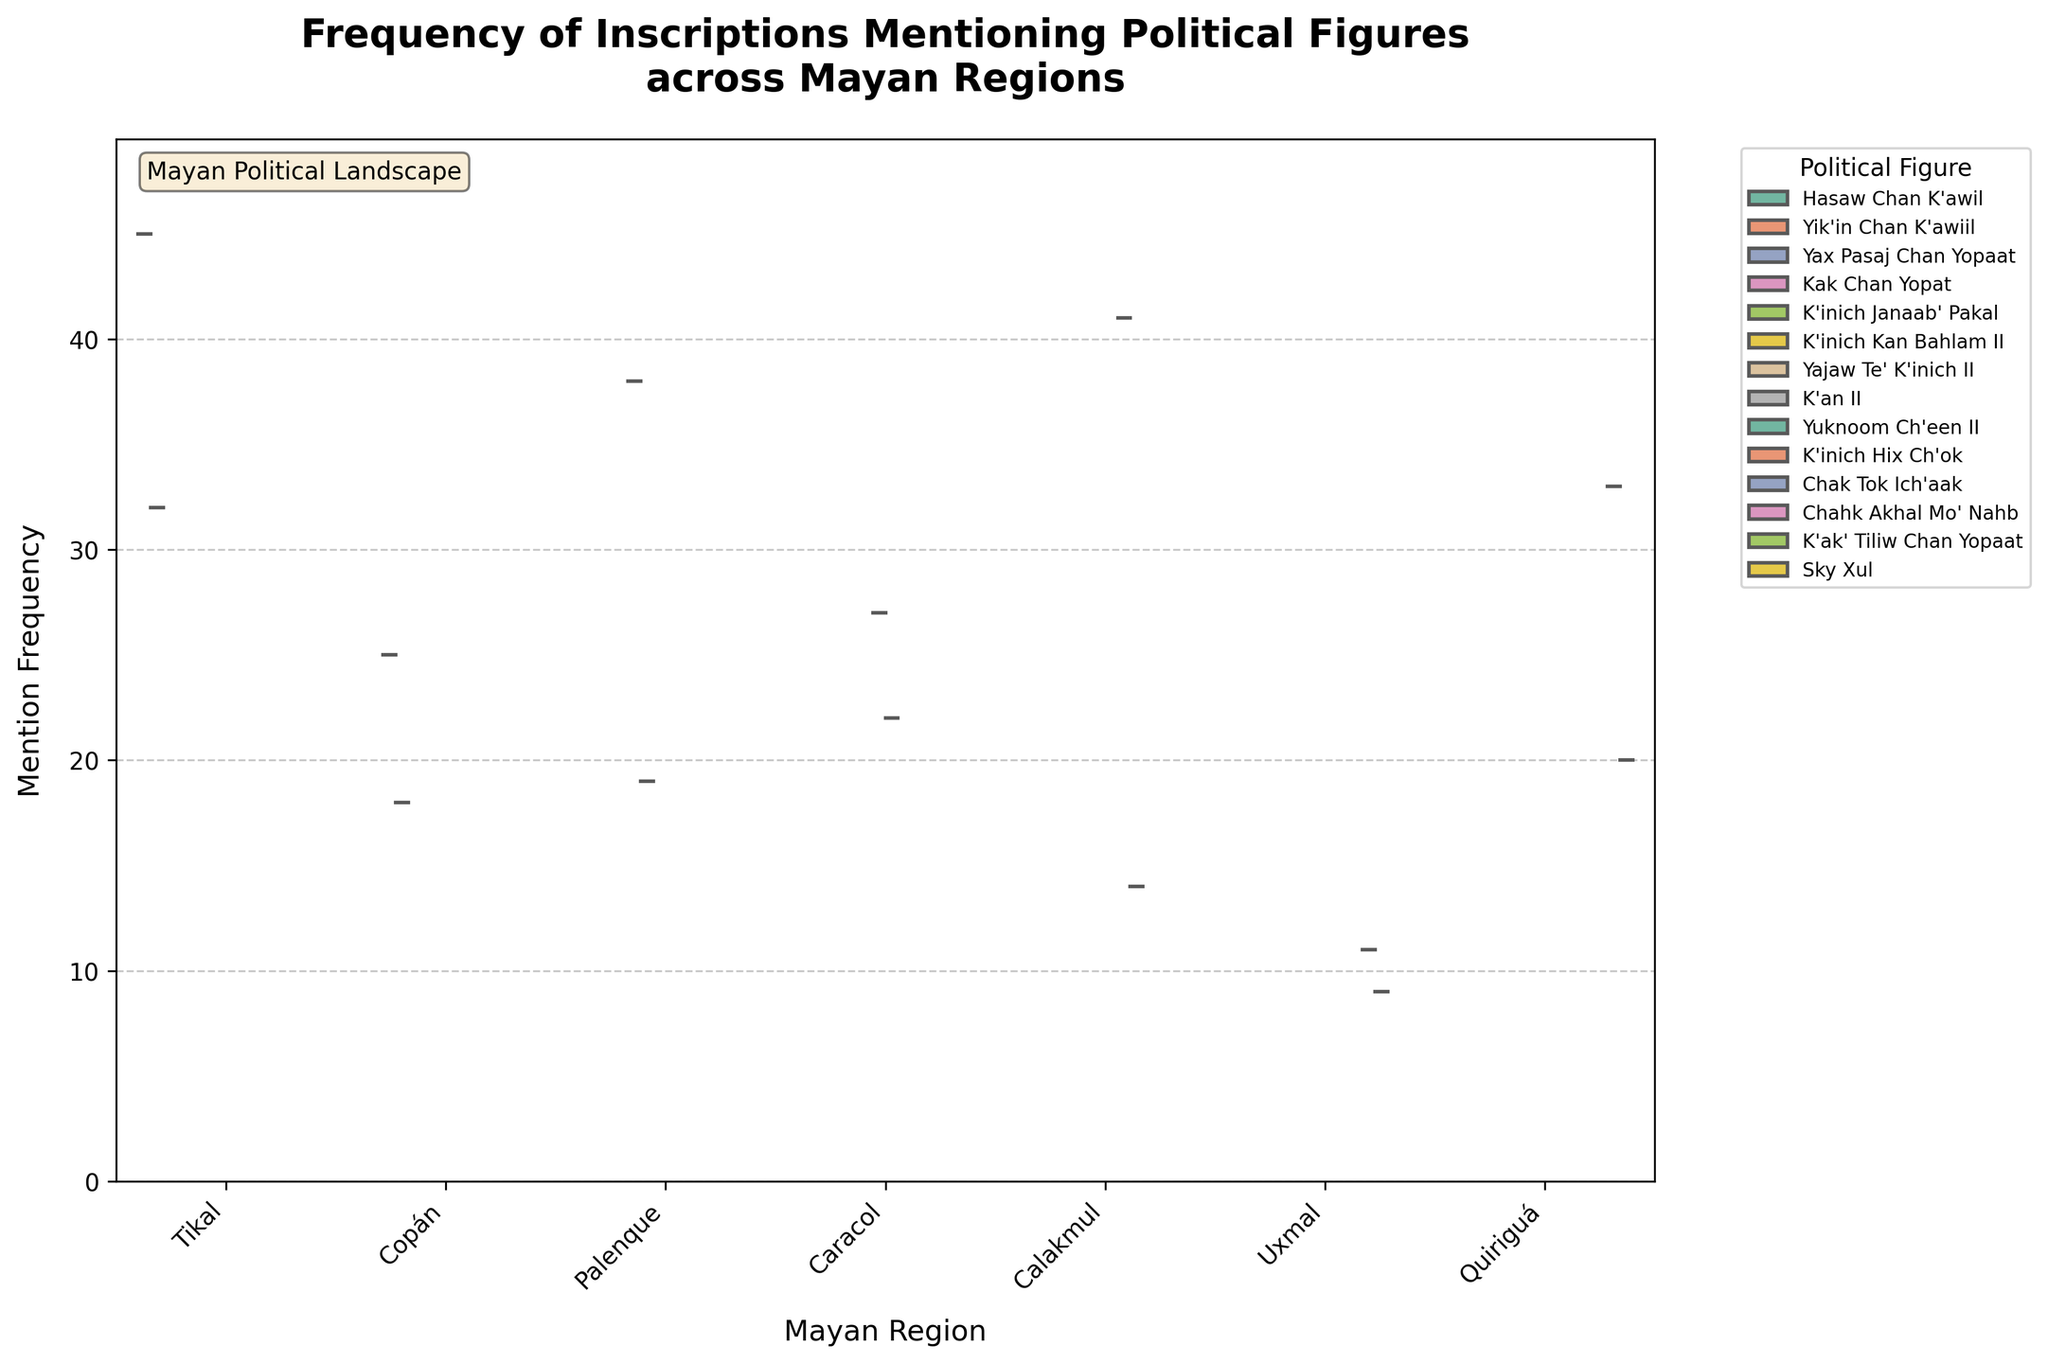What is the title of the plot? The title of the plot is usually found at the top of the figure in larger text. It summarizes the main topic of the plot. In this case, it is "Frequency of Inscriptions Mentioning Political Figures across Mayan Regions."
Answer: Frequency of Inscriptions Mentioning Political Figures across Mayan Regions Which region mentions political figures the most frequently? To determine this, observe the distribution of mention frequencies across the regions. Tikal has the highest frequency mentions with Hasaw Chan K'awil reaching a frequency of 45.
Answer: Tikal Which region has the lowest mention frequency of political figures? Look for the region with the lowest point on the y-axis. Uxmal has the lowest frequencies where Chak Tok Ich'aak has a mention frequency of 11 and Chahk Akhal Mo' Nahb has a mention frequency of 9.
Answer: Uxmal What is the median mention frequency for political figures in Tikal? The median is the middle value of the distribution of mentioned frequencies for Tikal. Visually, it's represented by the line inside the violin plot for Tikal. Yik'in Chan K'awiil at 32 and Hasaw Chan K'awil at 45 have their median between them.
Answer: Roughly 38.5 How does the mention frequency of Yik'in Chan K'awiil in Tikal compare to Yuknoom Ch'een II in Calakmul? Compare the frequencies directly by looking at their heights in the respective violin plots. Yik'in Chan K'awiil in Tikal has a mention frequency of 32, whereas Yuknoom Ch'een II in Calakmul has a mention frequency of 41.
Answer: Yik'in Chan K'awiil (32) is less than Yuknoom Ch'een II (41) What is the average mention frequency of political figures in Palenque? Add the frequencies of the political figures in Palenque and divide by the number of figures. Frequencies are 38 and 19. So, (38 + 19) / 2 = 28.5
Answer: 28.5 Compare the spread of mention frequencies between Tikal and Uxmal. Observe the width and range of the violin plots. Tikal's frequencies are more spread out (from 32 to 45) compared to Uxmal's narrower range (from 9 to 11).
Answer: Tikal's frequencies are more spread out Which political figure has the highest overall mention frequency? Identify the highest value across all violin plots. Hasaw Chan K'awil in Tikal has the highest mention frequency at 45.
Answer: Hasaw Chan K'awil Is there a political figure mentioned equally often in two different regions? Look for two regions that have the same height in their violin plots for at least one political figure. K'inich Kan Bahlam II in Palenque (19) and Kak Chan Yopat in Copán (18) are close but not equal. Hence, no political figure is mentioned equally often.
Answer: No 